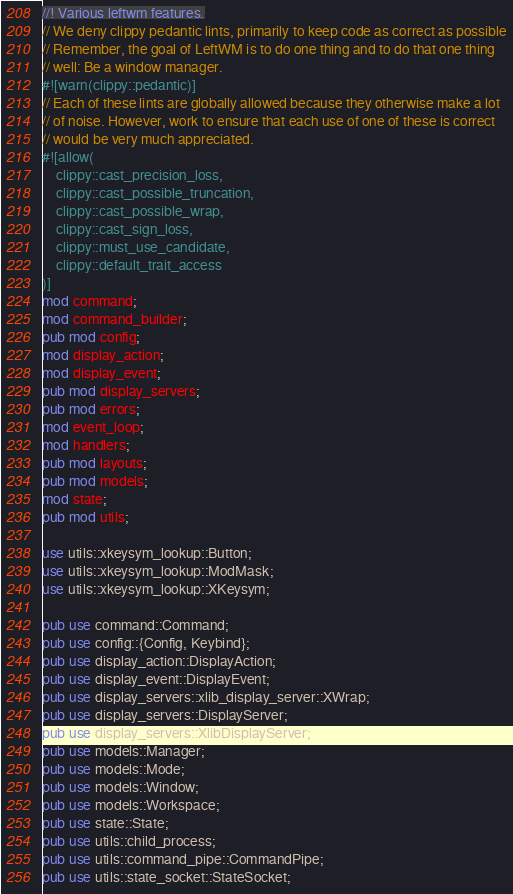Convert code to text. <code><loc_0><loc_0><loc_500><loc_500><_Rust_>//! Various leftwm features.
// We deny clippy pedantic lints, primarily to keep code as correct as possible
// Remember, the goal of LeftWM is to do one thing and to do that one thing
// well: Be a window manager.
#![warn(clippy::pedantic)]
// Each of these lints are globally allowed because they otherwise make a lot
// of noise. However, work to ensure that each use of one of these is correct
// would be very much appreciated.
#![allow(
    clippy::cast_precision_loss,
    clippy::cast_possible_truncation,
    clippy::cast_possible_wrap,
    clippy::cast_sign_loss,
    clippy::must_use_candidate,
    clippy::default_trait_access
)]
mod command;
mod command_builder;
pub mod config;
mod display_action;
mod display_event;
pub mod display_servers;
pub mod errors;
mod event_loop;
mod handlers;
pub mod layouts;
pub mod models;
mod state;
pub mod utils;

use utils::xkeysym_lookup::Button;
use utils::xkeysym_lookup::ModMask;
use utils::xkeysym_lookup::XKeysym;

pub use command::Command;
pub use config::{Config, Keybind};
pub use display_action::DisplayAction;
pub use display_event::DisplayEvent;
pub use display_servers::xlib_display_server::XWrap;
pub use display_servers::DisplayServer;
pub use display_servers::XlibDisplayServer;
pub use models::Manager;
pub use models::Mode;
pub use models::Window;
pub use models::Workspace;
pub use state::State;
pub use utils::child_process;
pub use utils::command_pipe::CommandPipe;
pub use utils::state_socket::StateSocket;
</code> 